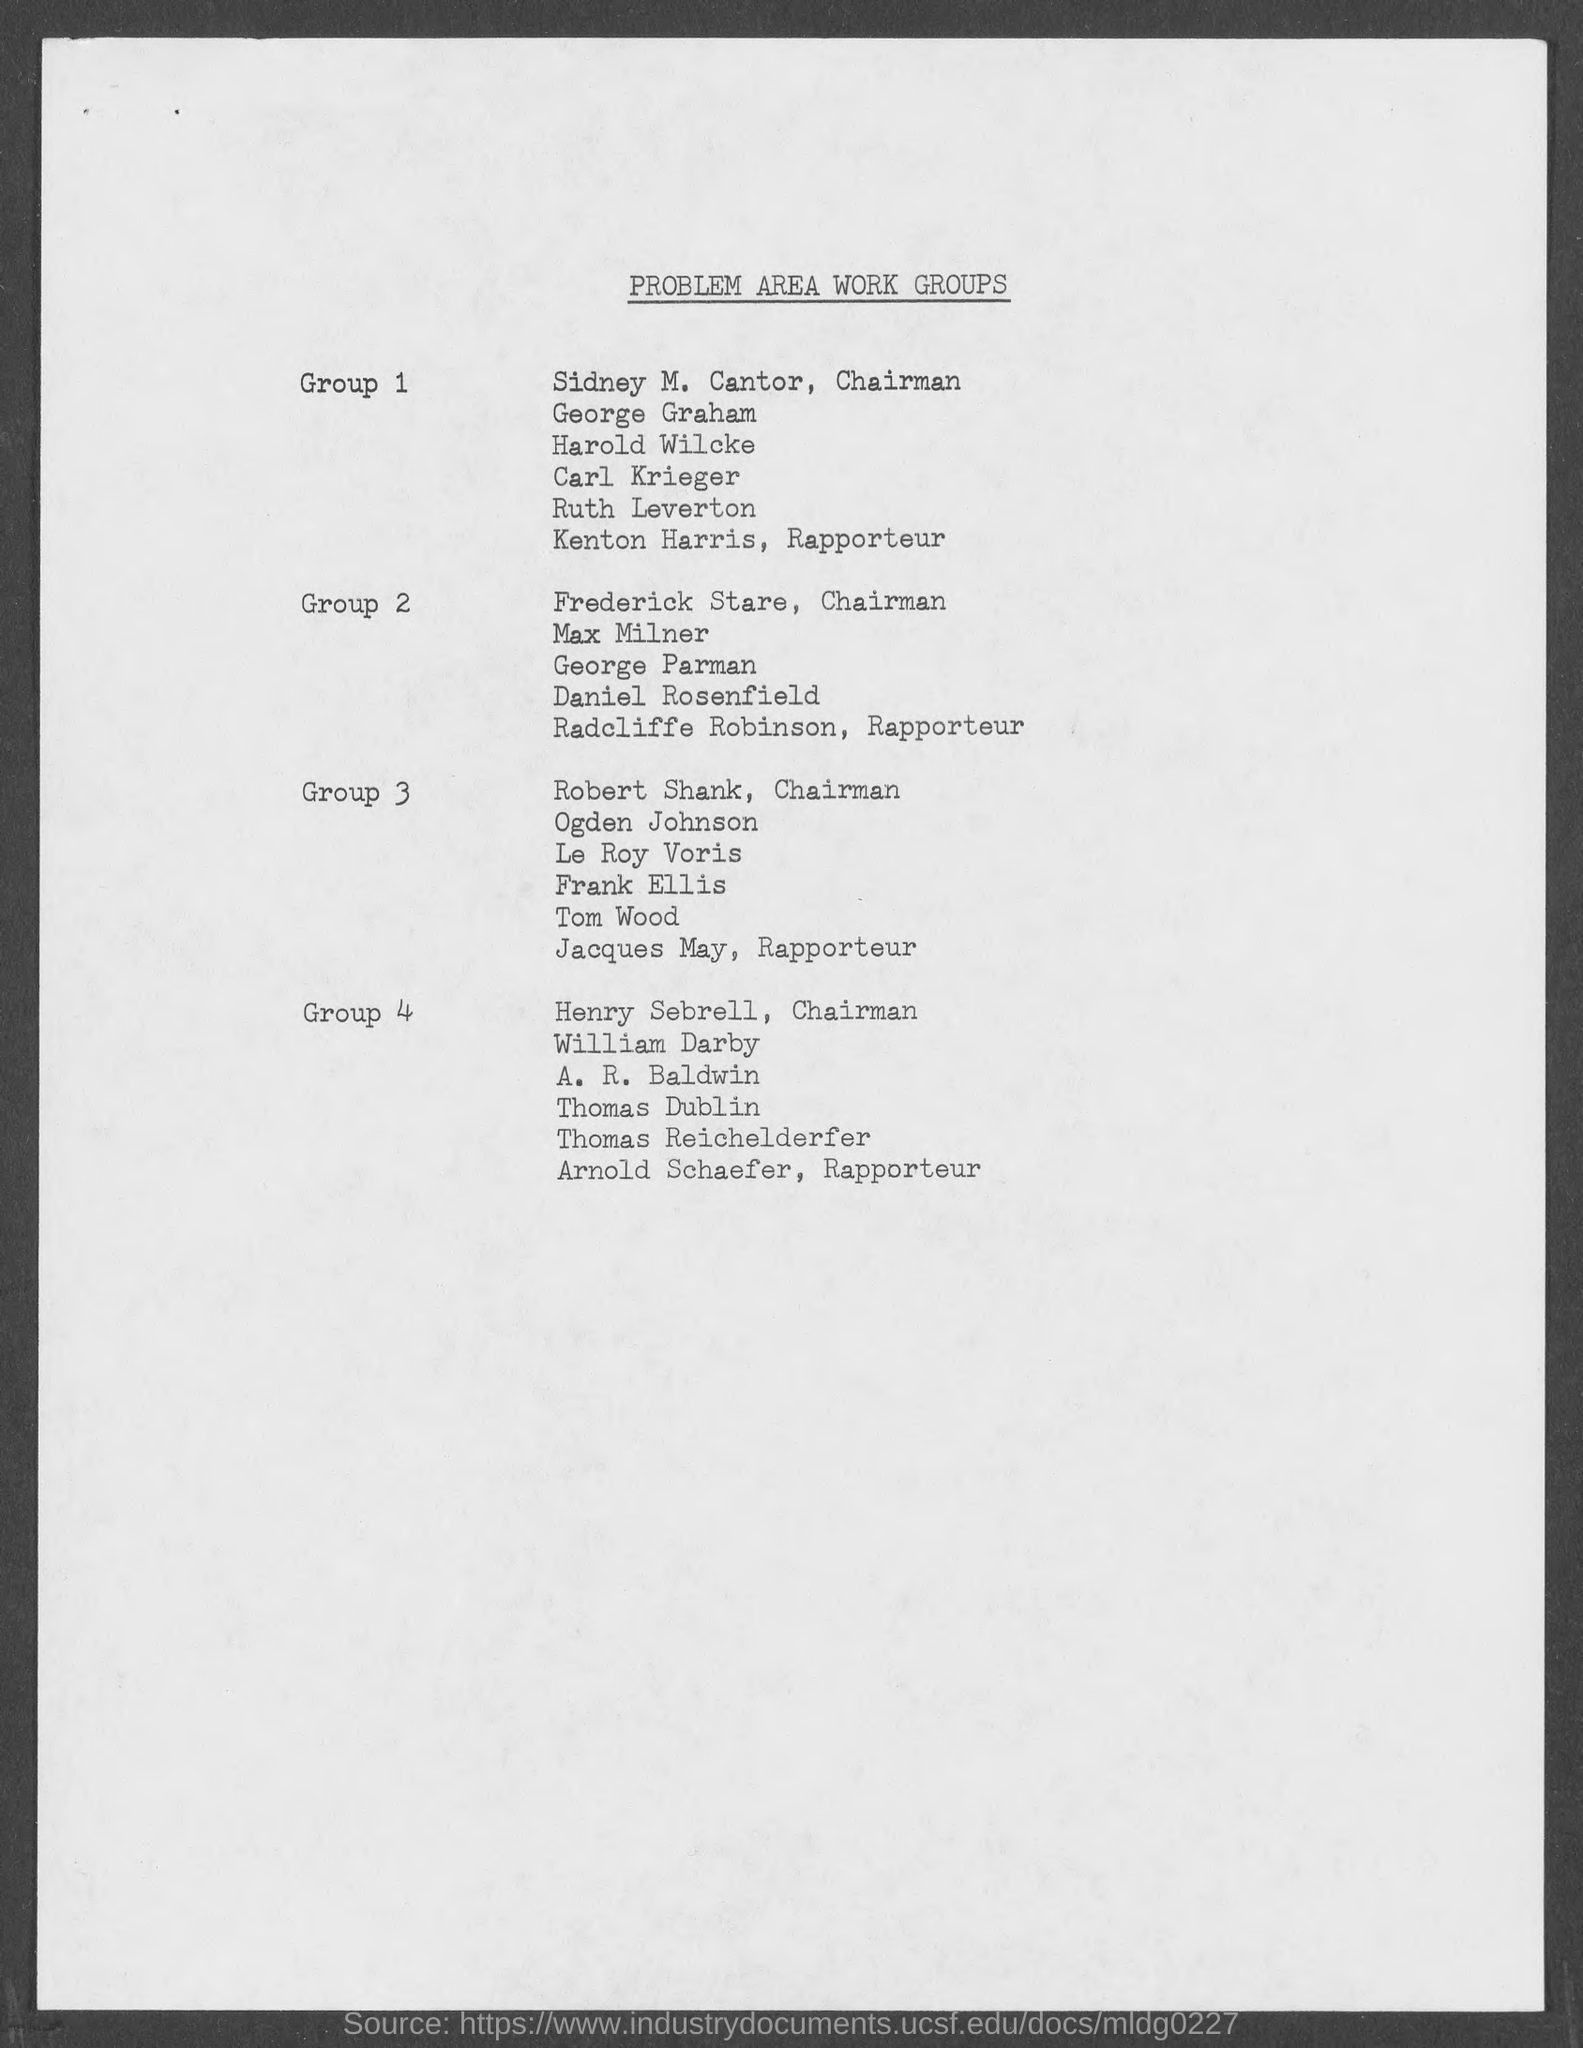Who is the chairman of group 1?
Make the answer very short. Sidney M. Cantor. Who is the chairman of group 2?
Keep it short and to the point. Frederick stare. Who is the chairman of group 3?
Make the answer very short. Robert shank. Who is the chairman of group 4?
Offer a terse response. Henry sebrell. Who is the rapporteur of group 1?
Offer a very short reply. Kenton harris. Who is the rapporteur of group 2?
Keep it short and to the point. Radcliffe Robinson. Who is the rapporteur of group 3?
Your response must be concise. Jacques May. Who is the rapporteur of group 4?
Make the answer very short. Arnold Schaefer. What is the heading of document on top?
Offer a very short reply. Problem area work groups. 